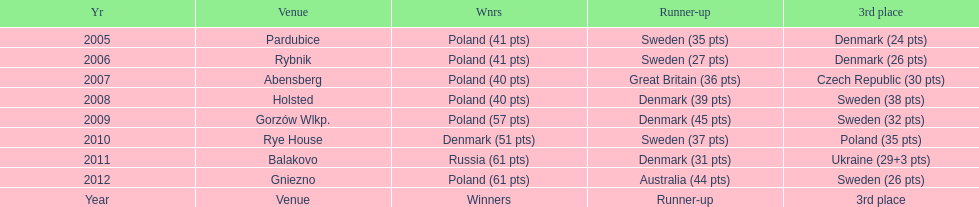When was the first year that poland did not place in the top three positions of the team speedway junior world championship? 2011. 